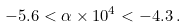Convert formula to latex. <formula><loc_0><loc_0><loc_500><loc_500>- 5 . 6 < \alpha \times 1 0 ^ { 4 } < - 4 . 3 \, .</formula> 